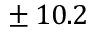Convert formula to latex. <formula><loc_0><loc_0><loc_500><loc_500>\pm \, 1 0 . 2</formula> 